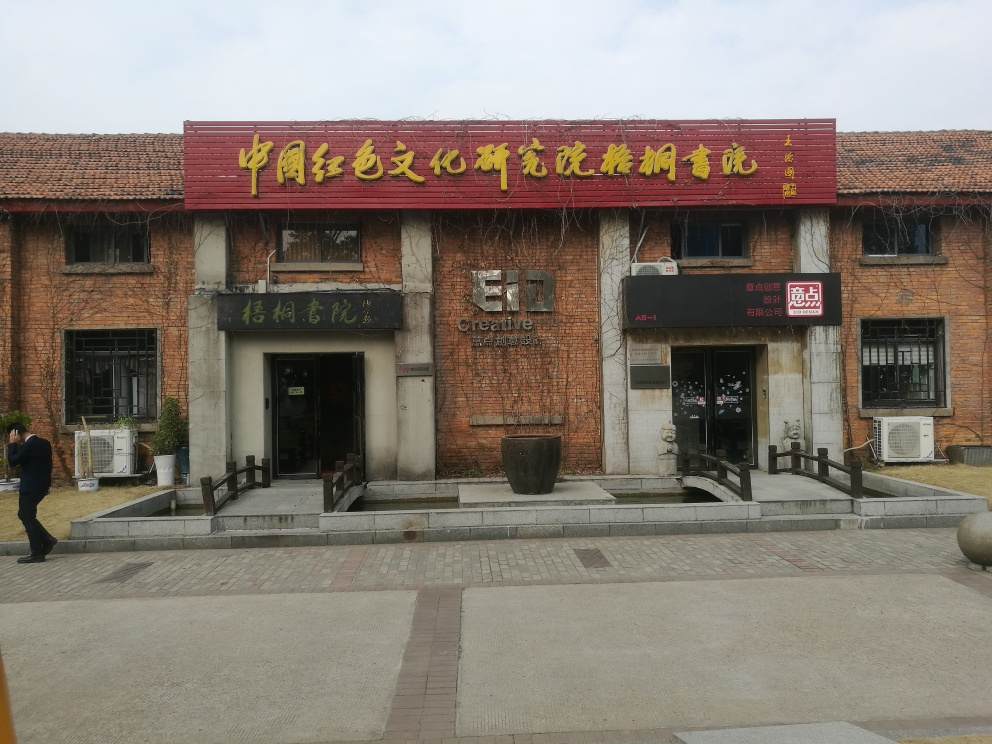Can you tell me about the architectural style of this building? The building exhibits characteristics of industrial architecture, evident from its exposed brick walls, large window openings, and minimalistic design. The style suggests it might have been repurposed for commercial or cultural use, reflecting a blend of historical and modern elements. 